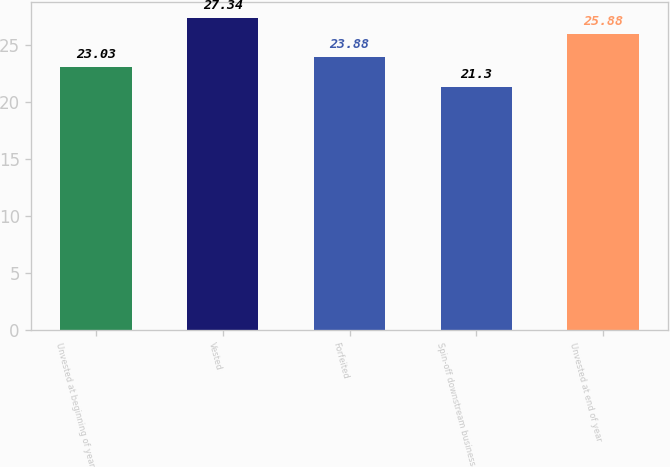Convert chart. <chart><loc_0><loc_0><loc_500><loc_500><bar_chart><fcel>Unvested at beginning of year<fcel>Vested<fcel>Forfeited<fcel>Spin-off downstream business<fcel>Unvested at end of year<nl><fcel>23.03<fcel>27.34<fcel>23.88<fcel>21.3<fcel>25.88<nl></chart> 